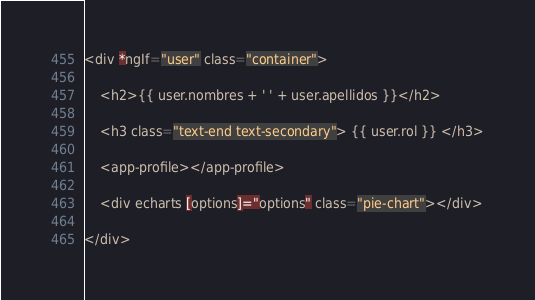<code> <loc_0><loc_0><loc_500><loc_500><_HTML_><div *ngIf="user" class="container">

    <h2>{{ user.nombres + ' ' + user.apellidos }}</h2>

    <h3 class="text-end text-secondary"> {{ user.rol }} </h3>

    <app-profile></app-profile>

    <div echarts [options]="options" class="pie-chart"></div>

</div></code> 